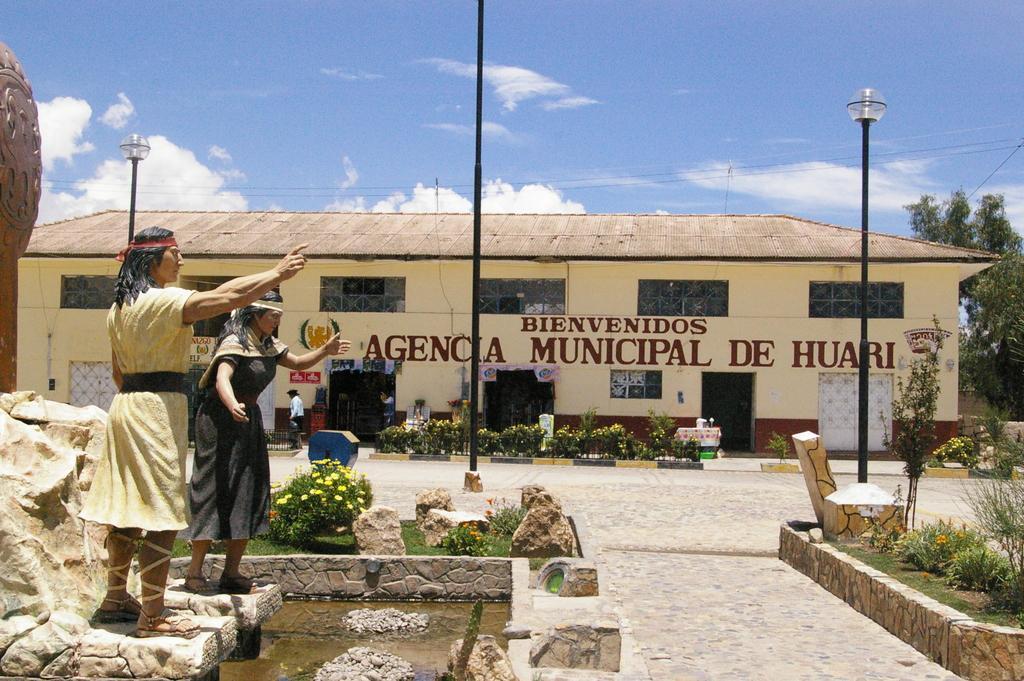Describe this image in one or two sentences. In this image I can see two people statues in different colors. Back I can see a building,windows,doors,signboards,light poles,trees,wires and small-plants. The sky is in blue and white color. 